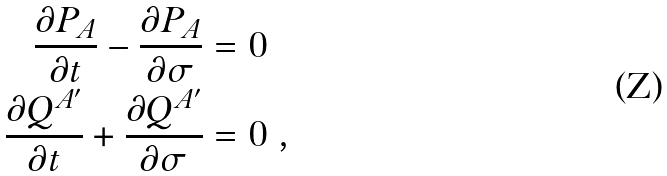<formula> <loc_0><loc_0><loc_500><loc_500>\frac { \partial P _ { A } } { \partial t } - \frac { \partial P _ { A } } { \partial \sigma } & = 0 \\ \frac { \partial Q ^ { A ^ { \prime } } } { \partial t } + \frac { \partial Q ^ { A ^ { \prime } } } { \partial \sigma } & = 0 \ ,</formula> 